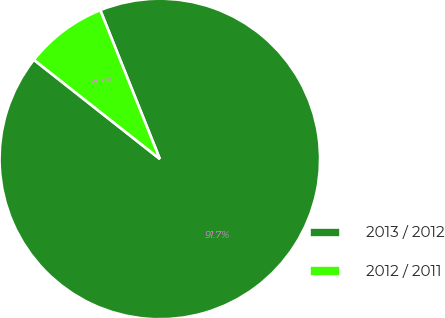<chart> <loc_0><loc_0><loc_500><loc_500><pie_chart><fcel>2013 / 2012<fcel>2012 / 2011<nl><fcel>91.67%<fcel>8.33%<nl></chart> 